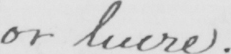Can you read and transcribe this handwriting? or lucre . 